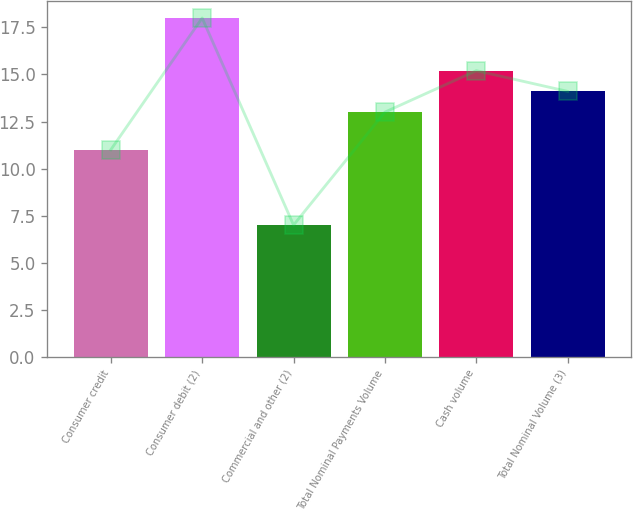Convert chart. <chart><loc_0><loc_0><loc_500><loc_500><bar_chart><fcel>Consumer credit<fcel>Consumer debit (2)<fcel>Commercial and other (2)<fcel>Total Nominal Payments Volume<fcel>Cash volume<fcel>Total Nominal Volume (3)<nl><fcel>11<fcel>18<fcel>7<fcel>13<fcel>15.2<fcel>14.1<nl></chart> 